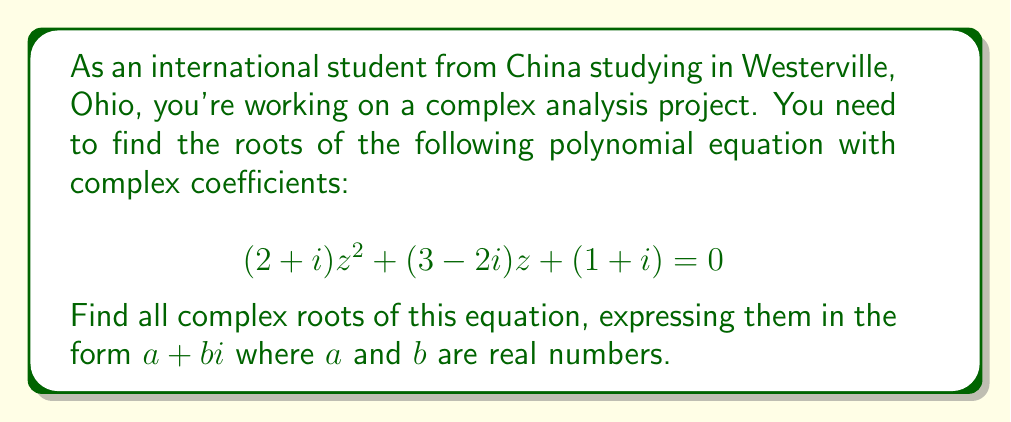Give your solution to this math problem. To solve this quadratic equation with complex coefficients, we'll use the quadratic formula:

$$z = \frac{-b \pm \sqrt{b^2 - 4ac}}{2a}$$

Where $a = 2+i$, $b = 3-2i$, and $c = 1+i$.

1) First, let's calculate $b^2$:
   $b^2 = (3-2i)^2 = 9 - 12i + 4i^2 = 5 - 12i$

2) Now, let's calculate $4ac$:
   $4ac = 4(2+i)(1+i) = 4(2+i+2i-1) = 4(1+3i) = 4 + 12i$

3) Subtract $4ac$ from $b^2$:
   $b^2 - 4ac = (5 - 12i) - (4 + 12i) = 1 - 24i$

4) Take the square root:
   $\sqrt{1 - 24i} = \sqrt{r}(\cos(\theta/2) + i\sin(\theta/2))$
   where $r = \sqrt{1^2 + 24^2} = \sqrt{577}$
   and $\theta = \arctan(-24) \approx -1.5308$
   
   So, $\sqrt{1 - 24i} \approx 24.0208 (-0.0208 - 0.9998i)$

5) Calculate $-b$:
   $-b = -(3-2i) = -3 + 2i$

6) Now we can apply the quadratic formula:
   $z = \frac{(-3+2i) \pm 24.0208(-0.0208-0.9998i)}{2(2+i)}$

7) Simplify the numerator and denominator:
   $z \approx \frac{(-3.5+2i) \pm (-0.5-24i)}{4+2i}$

8) Multiply by the complex conjugate of the denominator to rationalize:
   $z \approx \frac{[(-3.5+2i) \pm (-0.5-24i)](4-2i)}{(4+2i)(4-2i)} = \frac{[(-3.5+2i) \pm (-0.5-24i)](4-2i)}{20}$

9) Expand and simplify to get the two roots.
Answer: The two complex roots of the equation are approximately:

$z_1 \approx -0.9 + 0.8i$
$z_2 \approx -0.6 - 1.3i$ 